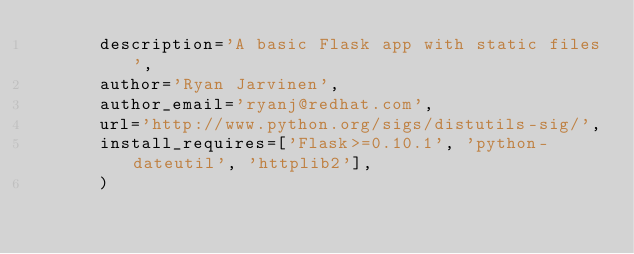Convert code to text. <code><loc_0><loc_0><loc_500><loc_500><_Python_>      description='A basic Flask app with static files',
      author='Ryan Jarvinen',
      author_email='ryanj@redhat.com',
      url='http://www.python.org/sigs/distutils-sig/',
      install_requires=['Flask>=0.10.1', 'python-dateutil', 'httplib2'],
      )
</code> 